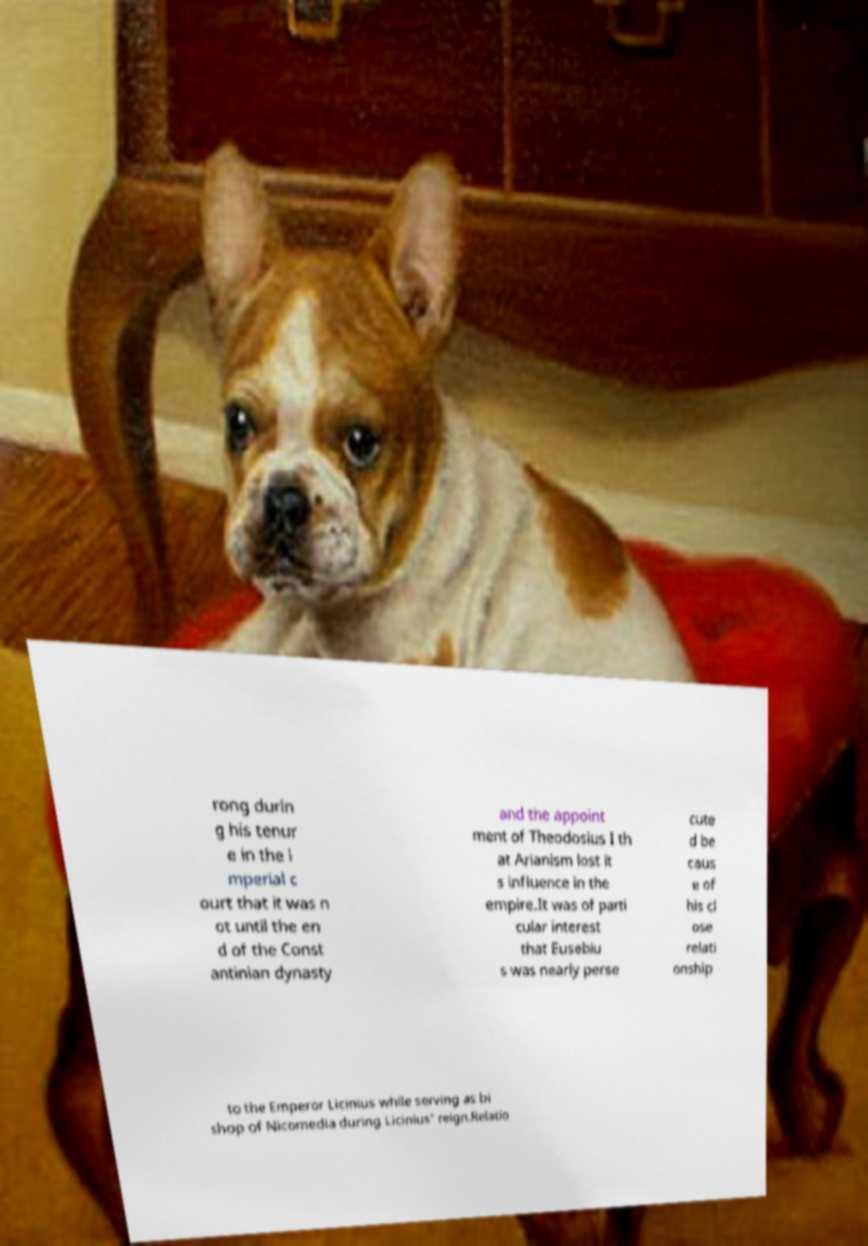Could you extract and type out the text from this image? rong durin g his tenur e in the i mperial c ourt that it was n ot until the en d of the Const antinian dynasty and the appoint ment of Theodosius I th at Arianism lost it s influence in the empire.It was of parti cular interest that Eusebiu s was nearly perse cute d be caus e of his cl ose relati onship to the Emperor Licinius while serving as bi shop of Nicomedia during Licinius' reign.Relatio 